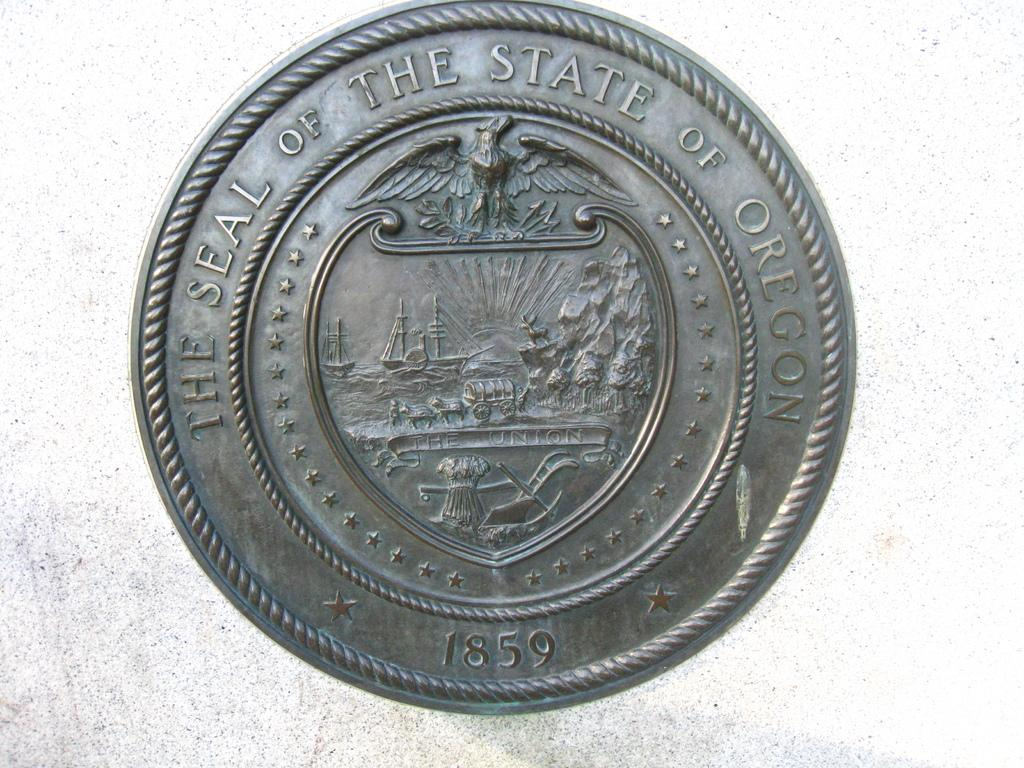Provide a one-sentence caption for the provided image. A silver coin with the imprint 1859 on the bottom and the words, The Seal of the State of Oregon imprinted on the top. 